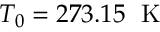Convert formula to latex. <formula><loc_0><loc_0><loc_500><loc_500>{ { T } _ { 0 } } = 2 7 3 . 1 5 \, K</formula> 